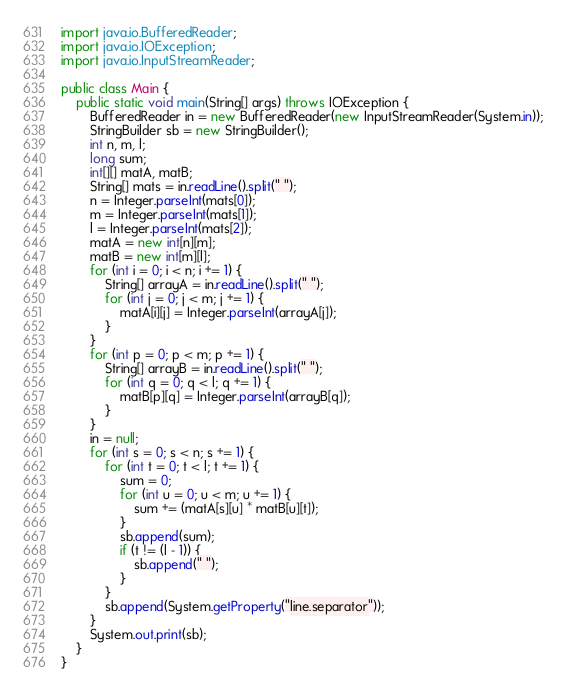Convert code to text. <code><loc_0><loc_0><loc_500><loc_500><_Java_>import java.io.BufferedReader;
import java.io.IOException;
import java.io.InputStreamReader;

public class Main {
	public static void main(String[] args) throws IOException {
		BufferedReader in = new BufferedReader(new InputStreamReader(System.in));
		StringBuilder sb = new StringBuilder();
		int n, m, l;
		long sum;
		int[][] matA, matB;
		String[] mats = in.readLine().split(" ");
		n = Integer.parseInt(mats[0]);
		m = Integer.parseInt(mats[1]);
		l = Integer.parseInt(mats[2]);
		matA = new int[n][m];
		matB = new int[m][l];
		for (int i = 0; i < n; i += 1) {
			String[] arrayA = in.readLine().split(" ");
			for (int j = 0; j < m; j += 1) {
				matA[i][j] = Integer.parseInt(arrayA[j]);
			}
		}
		for (int p = 0; p < m; p += 1) {
			String[] arrayB = in.readLine().split(" ");
			for (int q = 0; q < l; q += 1) {
				matB[p][q] = Integer.parseInt(arrayB[q]);
			}
		}
		in = null;
		for (int s = 0; s < n; s += 1) {
			for (int t = 0; t < l; t += 1) {
				sum = 0;
				for (int u = 0; u < m; u += 1) {
					sum += (matA[s][u] * matB[u][t]);
				}
				sb.append(sum);
				if (t != (l - 1)) {
					sb.append(" ");
				}
			}
			sb.append(System.getProperty("line.separator"));
		}
		System.out.print(sb);
	}
}</code> 